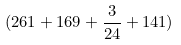<formula> <loc_0><loc_0><loc_500><loc_500>( 2 6 1 + 1 6 9 + \frac { 3 } { 2 4 } + 1 4 1 )</formula> 